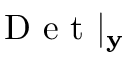<formula> <loc_0><loc_0><loc_500><loc_500>D e t | _ { y }</formula> 